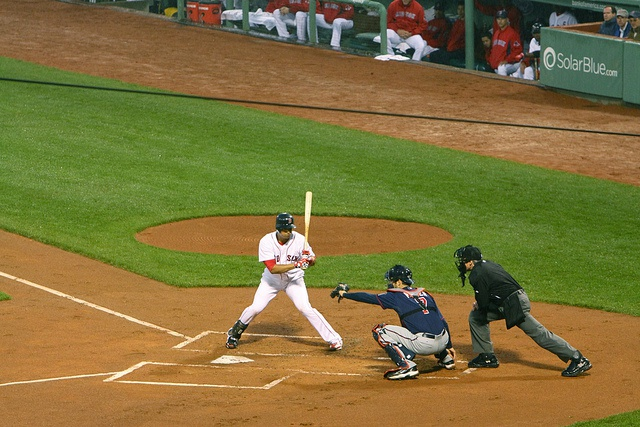Describe the objects in this image and their specific colors. I can see people in olive, black, gray, and darkgreen tones, people in olive, black, navy, lightgray, and darkgray tones, people in olive, lavender, darkgray, black, and gray tones, people in olive, maroon, lavender, gray, and brown tones, and people in olive, black, maroon, gray, and lightgray tones in this image. 